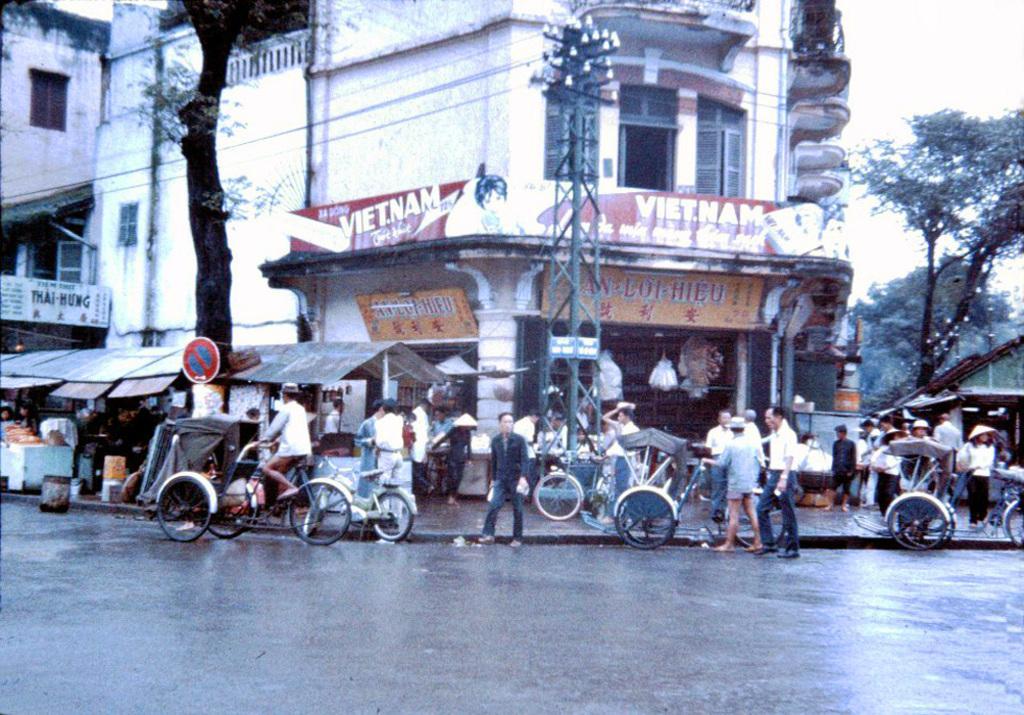Describe this image in one or two sentences. In this image, in the middle there are many people, some are walking, some are driving vehicles and there are sign boards, tents, buildings, electric pole, cables, trees, shops, road, vehicles, sky. 